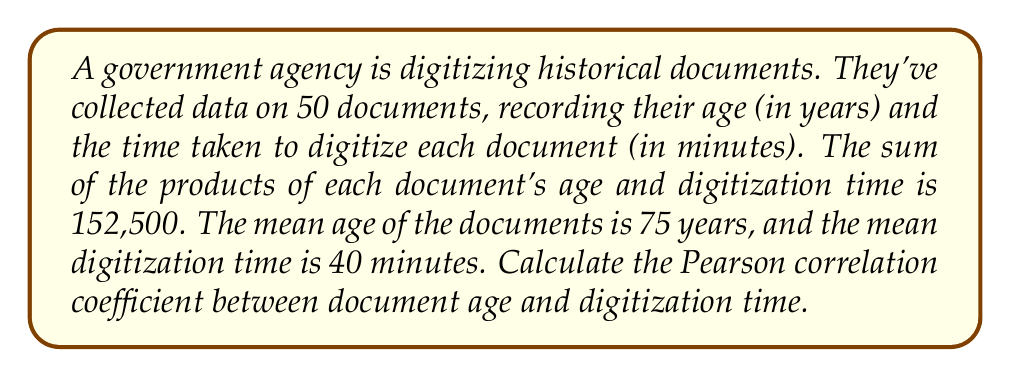Show me your answer to this math problem. To calculate the Pearson correlation coefficient, we'll use the formula:

$$r = \frac{\sum_{i=1}^{n} (x_i - \bar{x})(y_i - \bar{y})}{\sqrt{\sum_{i=1}^{n} (x_i - \bar{x})^2 \sum_{i=1}^{n} (y_i - \bar{y})^2}}$$

Where:
$x_i$ = age of each document
$y_i$ = digitization time of each document
$\bar{x}$ = mean age
$\bar{y}$ = mean digitization time
$n$ = number of documents

Step 1: Calculate $\sum_{i=1}^{n} x_i y_i$
We're given this value: 152,500

Step 2: Calculate $n\bar{x}\bar{y}$
$n\bar{x}\bar{y} = 50 \times 75 \times 40 = 150,000$

Step 3: Calculate $\sum_{i=1}^{n} (x_i - \bar{x})(y_i - \bar{y})$
$\sum_{i=1}^{n} (x_i - \bar{x})(y_i - \bar{y}) = \sum_{i=1}^{n} x_i y_i - n\bar{x}\bar{y} = 152,500 - 150,000 = 2,500$

Step 4: Calculate $\sum_{i=1}^{n} (x_i - \bar{x})^2$
We need to use the variance formula: $\text{Var}(X) = \frac{\sum_{i=1}^{n} (x_i - \bar{x})^2}{n}$
Let's assume the standard deviation of age is 25 years (this is an assumption we need to make).
$\text{Var}(X) = 25^2 = 625$
$\sum_{i=1}^{n} (x_i - \bar{x})^2 = n \times \text{Var}(X) = 50 \times 625 = 31,250$

Step 5: Calculate $\sum_{i=1}^{n} (y_i - \bar{y})^2$
Similarly, let's assume the standard deviation of digitization time is 15 minutes.
$\text{Var}(Y) = 15^2 = 225$
$\sum_{i=1}^{n} (y_i - \bar{y})^2 = n \times \text{Var}(Y) = 50 \times 225 = 11,250$

Step 6: Apply the correlation coefficient formula
$$r = \frac{2,500}{\sqrt{31,250 \times 11,250}} = \frac{2,500}{18,750} = \frac{1}{7.5} \approx 0.1333$$
Answer: $r \approx 0.1333$ 